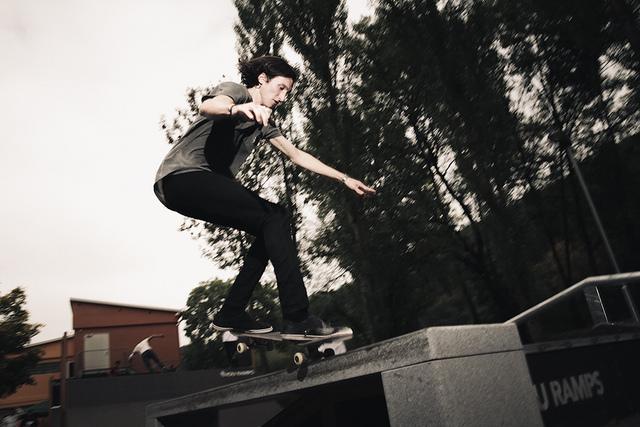Is he going to fall?
Concise answer only. No. What weather is that?
Write a very short answer. Overcast. What is the term for the thing these skaters are skating in?
Write a very short answer. Park. How many people are shown in the photo?
Concise answer only. 2. What game is the man playing?
Short answer required. Skateboarding. What is this person riding?
Be succinct. Skateboard. Is this a color photo?
Short answer required. Yes. Is this a park that is designated for skateboarding?
Keep it brief. Yes. Are his shoes generic?
Give a very brief answer. Yes. How many skater's are shown?
Give a very brief answer. 1. Is the man surfing?
Short answer required. No. What is this person balancing on?
Be succinct. Skateboard. What color is the fence?
Write a very short answer. Black. How many feet are on the board?
Give a very brief answer. 2. Is the skateboard in the air?
Quick response, please. No. What is the bench made of?
Give a very brief answer. Concrete. What is the man doing in the air with skateboard?
Write a very short answer. Trick. What does the bottom say?
Keep it brief. Ramps. Is this person going to jump into the snow?
Keep it brief. No. What color is the man wearing?
Answer briefly. Black. 